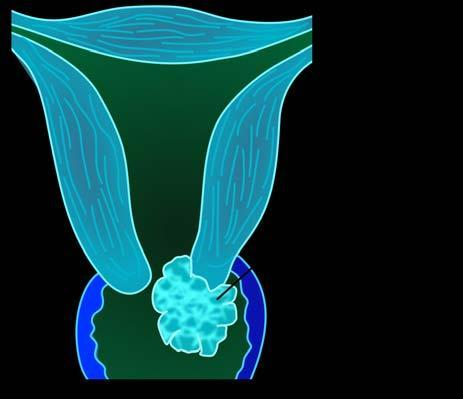s the granuloma of a fungating or exophytic, cauliflower-like tumour?
Answer the question using a single word or phrase. No 